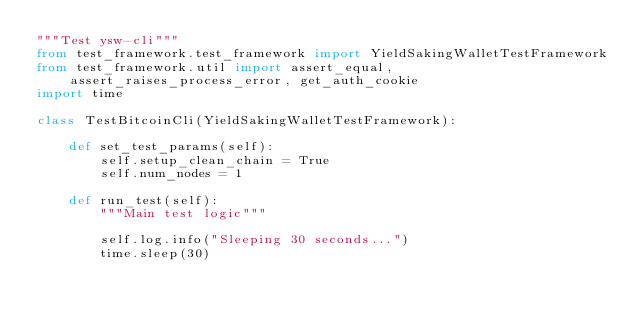<code> <loc_0><loc_0><loc_500><loc_500><_Python_>"""Test ysw-cli"""
from test_framework.test_framework import YieldSakingWalletTestFramework
from test_framework.util import assert_equal, assert_raises_process_error, get_auth_cookie
import time

class TestBitcoinCli(YieldSakingWalletTestFramework):

    def set_test_params(self):
        self.setup_clean_chain = True
        self.num_nodes = 1

    def run_test(self):
        """Main test logic"""

        self.log.info("Sleeping 30 seconds...")
        time.sleep(30)
</code> 